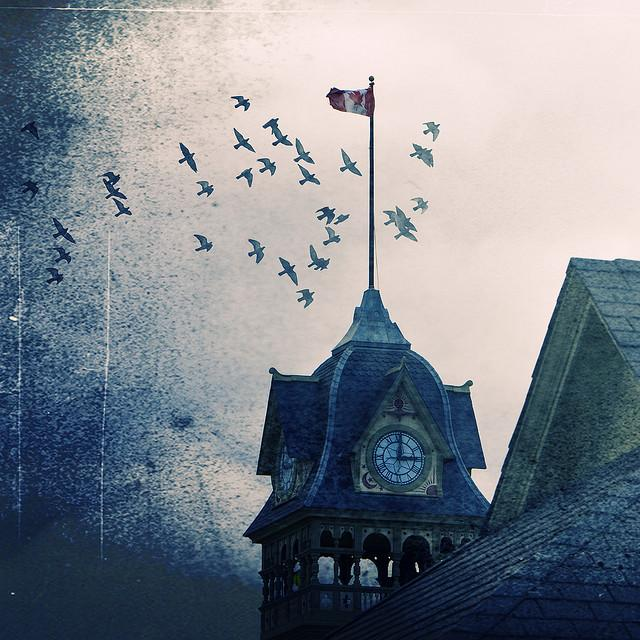What nation's flag are the birds flying towards? Please explain your reasoning. canada. The flag has two vertical red bars around a white center with a red maple leaf. this is the flag of canada. 